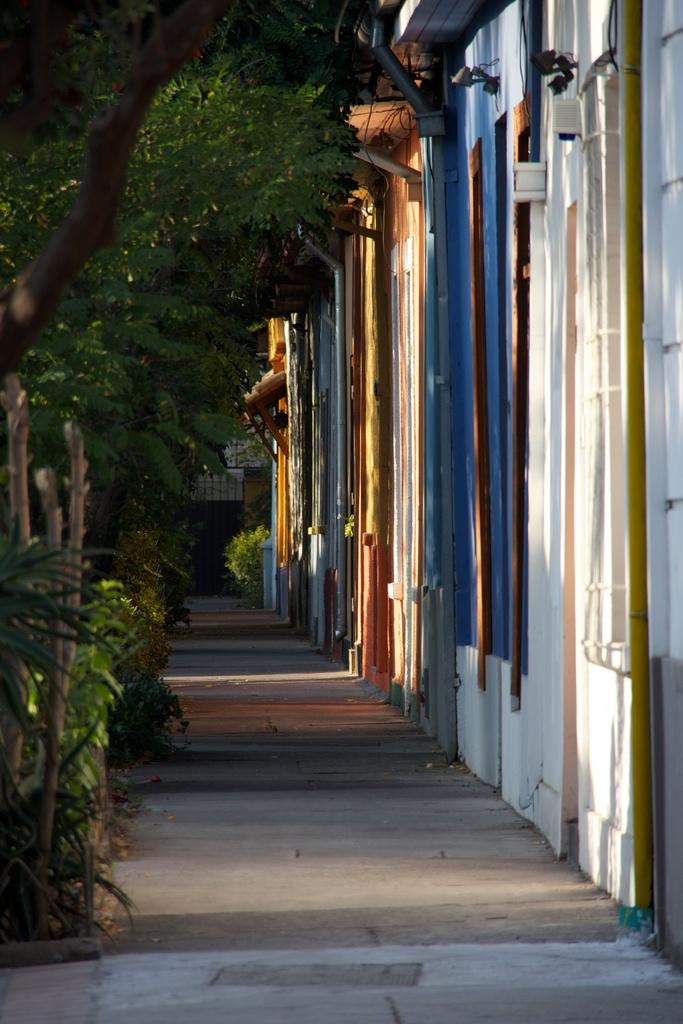What type of structures can be seen on the right side of the image? There are buildings on the right side of the image. What type of vegetation is on the left side of the image? There are trees on the left side of the image. Can you see any steam coming from the sidewalk in the image? There is no sidewalk or steam present in the image. How does the pull of gravity affect the buildings in the image? The image does not provide information about the pull of gravity on the buildings, and it is not possible to determine this from the image alone. 